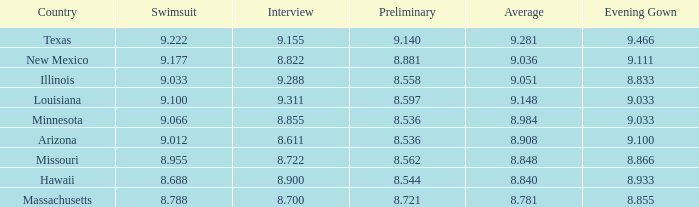What was the swimsuit score for the country with the average score of 8.848? 8.955. 